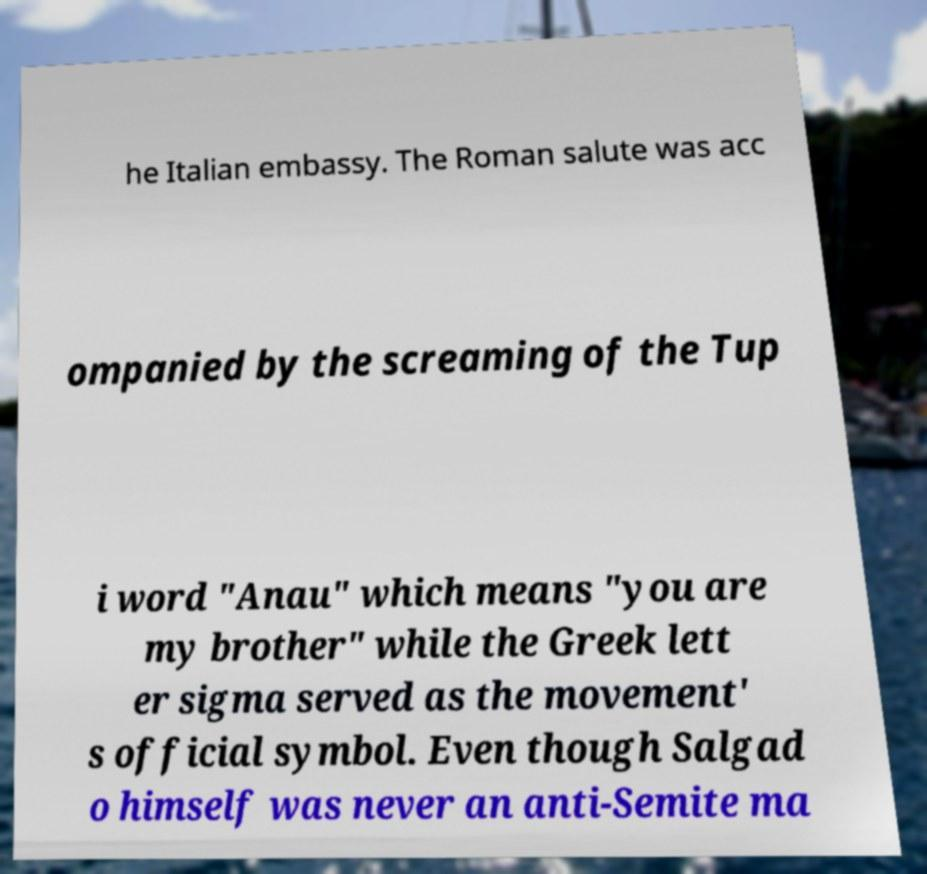There's text embedded in this image that I need extracted. Can you transcribe it verbatim? he Italian embassy. The Roman salute was acc ompanied by the screaming of the Tup i word "Anau" which means "you are my brother" while the Greek lett er sigma served as the movement' s official symbol. Even though Salgad o himself was never an anti-Semite ma 